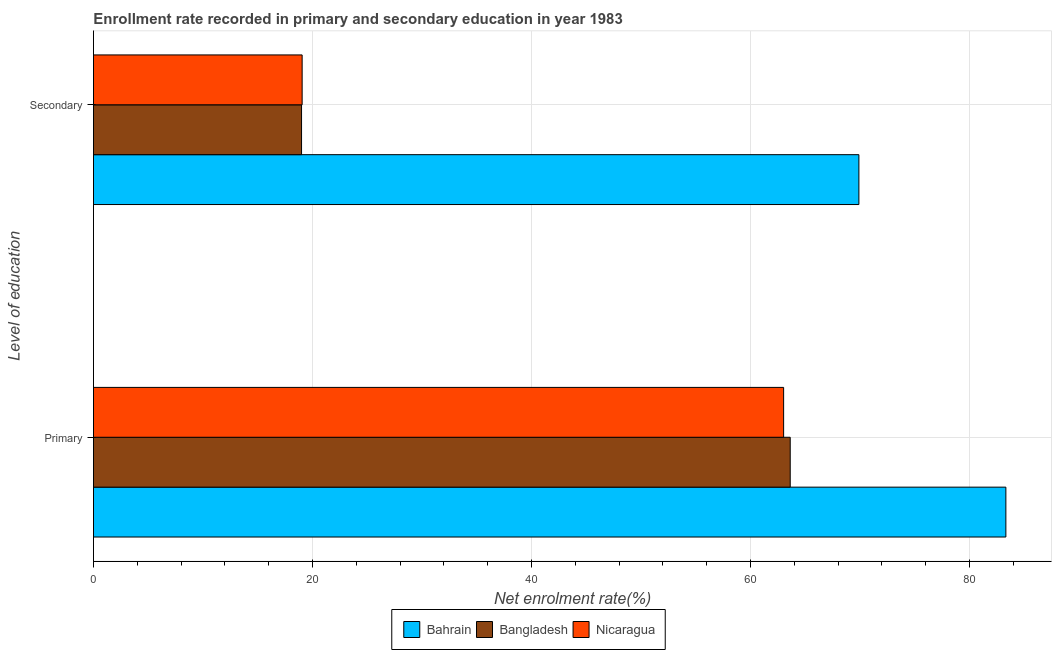Are the number of bars per tick equal to the number of legend labels?
Provide a short and direct response. Yes. Are the number of bars on each tick of the Y-axis equal?
Offer a terse response. Yes. How many bars are there on the 1st tick from the top?
Give a very brief answer. 3. How many bars are there on the 1st tick from the bottom?
Make the answer very short. 3. What is the label of the 2nd group of bars from the top?
Offer a very short reply. Primary. What is the enrollment rate in primary education in Nicaragua?
Provide a succinct answer. 63.03. Across all countries, what is the maximum enrollment rate in secondary education?
Your answer should be compact. 69.9. Across all countries, what is the minimum enrollment rate in secondary education?
Keep it short and to the point. 19. In which country was the enrollment rate in secondary education maximum?
Your response must be concise. Bahrain. In which country was the enrollment rate in primary education minimum?
Your response must be concise. Nicaragua. What is the total enrollment rate in primary education in the graph?
Your response must be concise. 209.98. What is the difference between the enrollment rate in secondary education in Bahrain and that in Bangladesh?
Offer a terse response. 50.9. What is the difference between the enrollment rate in secondary education in Bahrain and the enrollment rate in primary education in Nicaragua?
Make the answer very short. 6.87. What is the average enrollment rate in primary education per country?
Provide a short and direct response. 69.99. What is the difference between the enrollment rate in secondary education and enrollment rate in primary education in Bahrain?
Your answer should be very brief. -13.42. What is the ratio of the enrollment rate in secondary education in Bangladesh to that in Bahrain?
Give a very brief answer. 0.27. Is the enrollment rate in primary education in Nicaragua less than that in Bahrain?
Your answer should be compact. Yes. In how many countries, is the enrollment rate in secondary education greater than the average enrollment rate in secondary education taken over all countries?
Keep it short and to the point. 1. What does the 2nd bar from the top in Primary represents?
Your answer should be compact. Bangladesh. What does the 1st bar from the bottom in Primary represents?
Offer a terse response. Bahrain. Are all the bars in the graph horizontal?
Offer a very short reply. Yes. How many countries are there in the graph?
Keep it short and to the point. 3. Does the graph contain grids?
Keep it short and to the point. Yes. How are the legend labels stacked?
Your answer should be very brief. Horizontal. What is the title of the graph?
Your answer should be very brief. Enrollment rate recorded in primary and secondary education in year 1983. What is the label or title of the X-axis?
Offer a terse response. Net enrolment rate(%). What is the label or title of the Y-axis?
Give a very brief answer. Level of education. What is the Net enrolment rate(%) of Bahrain in Primary?
Give a very brief answer. 83.32. What is the Net enrolment rate(%) in Bangladesh in Primary?
Provide a succinct answer. 63.63. What is the Net enrolment rate(%) of Nicaragua in Primary?
Offer a very short reply. 63.03. What is the Net enrolment rate(%) of Bahrain in Secondary?
Keep it short and to the point. 69.9. What is the Net enrolment rate(%) of Bangladesh in Secondary?
Make the answer very short. 19. What is the Net enrolment rate(%) of Nicaragua in Secondary?
Offer a very short reply. 19.06. Across all Level of education, what is the maximum Net enrolment rate(%) in Bahrain?
Your answer should be very brief. 83.32. Across all Level of education, what is the maximum Net enrolment rate(%) in Bangladesh?
Your answer should be very brief. 63.63. Across all Level of education, what is the maximum Net enrolment rate(%) of Nicaragua?
Provide a succinct answer. 63.03. Across all Level of education, what is the minimum Net enrolment rate(%) of Bahrain?
Provide a short and direct response. 69.9. Across all Level of education, what is the minimum Net enrolment rate(%) in Bangladesh?
Your response must be concise. 19. Across all Level of education, what is the minimum Net enrolment rate(%) in Nicaragua?
Offer a terse response. 19.06. What is the total Net enrolment rate(%) of Bahrain in the graph?
Your answer should be compact. 153.23. What is the total Net enrolment rate(%) of Bangladesh in the graph?
Offer a terse response. 82.63. What is the total Net enrolment rate(%) in Nicaragua in the graph?
Give a very brief answer. 82.08. What is the difference between the Net enrolment rate(%) of Bahrain in Primary and that in Secondary?
Your answer should be compact. 13.42. What is the difference between the Net enrolment rate(%) in Bangladesh in Primary and that in Secondary?
Give a very brief answer. 44.63. What is the difference between the Net enrolment rate(%) of Nicaragua in Primary and that in Secondary?
Offer a terse response. 43.97. What is the difference between the Net enrolment rate(%) in Bahrain in Primary and the Net enrolment rate(%) in Bangladesh in Secondary?
Make the answer very short. 64.32. What is the difference between the Net enrolment rate(%) in Bahrain in Primary and the Net enrolment rate(%) in Nicaragua in Secondary?
Offer a very short reply. 64.27. What is the difference between the Net enrolment rate(%) of Bangladesh in Primary and the Net enrolment rate(%) of Nicaragua in Secondary?
Ensure brevity in your answer.  44.57. What is the average Net enrolment rate(%) of Bahrain per Level of education?
Keep it short and to the point. 76.61. What is the average Net enrolment rate(%) in Bangladesh per Level of education?
Give a very brief answer. 41.32. What is the average Net enrolment rate(%) in Nicaragua per Level of education?
Offer a terse response. 41.04. What is the difference between the Net enrolment rate(%) in Bahrain and Net enrolment rate(%) in Bangladesh in Primary?
Make the answer very short. 19.69. What is the difference between the Net enrolment rate(%) of Bahrain and Net enrolment rate(%) of Nicaragua in Primary?
Keep it short and to the point. 20.3. What is the difference between the Net enrolment rate(%) in Bangladesh and Net enrolment rate(%) in Nicaragua in Primary?
Offer a very short reply. 0.6. What is the difference between the Net enrolment rate(%) of Bahrain and Net enrolment rate(%) of Bangladesh in Secondary?
Offer a very short reply. 50.9. What is the difference between the Net enrolment rate(%) of Bahrain and Net enrolment rate(%) of Nicaragua in Secondary?
Keep it short and to the point. 50.84. What is the difference between the Net enrolment rate(%) of Bangladesh and Net enrolment rate(%) of Nicaragua in Secondary?
Your response must be concise. -0.05. What is the ratio of the Net enrolment rate(%) in Bahrain in Primary to that in Secondary?
Your response must be concise. 1.19. What is the ratio of the Net enrolment rate(%) in Bangladesh in Primary to that in Secondary?
Keep it short and to the point. 3.35. What is the ratio of the Net enrolment rate(%) in Nicaragua in Primary to that in Secondary?
Offer a very short reply. 3.31. What is the difference between the highest and the second highest Net enrolment rate(%) of Bahrain?
Provide a succinct answer. 13.42. What is the difference between the highest and the second highest Net enrolment rate(%) of Bangladesh?
Provide a succinct answer. 44.63. What is the difference between the highest and the second highest Net enrolment rate(%) of Nicaragua?
Keep it short and to the point. 43.97. What is the difference between the highest and the lowest Net enrolment rate(%) in Bahrain?
Provide a succinct answer. 13.42. What is the difference between the highest and the lowest Net enrolment rate(%) in Bangladesh?
Offer a terse response. 44.63. What is the difference between the highest and the lowest Net enrolment rate(%) of Nicaragua?
Your answer should be very brief. 43.97. 